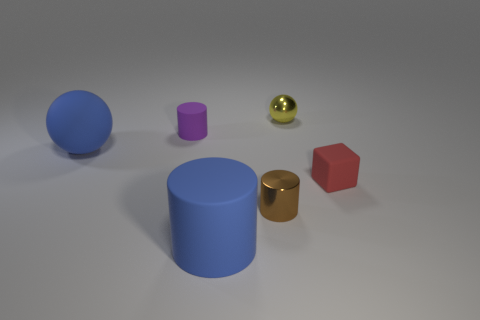Add 2 rubber cylinders. How many objects exist? 8 Subtract all big cylinders. How many cylinders are left? 2 Subtract all brown cylinders. How many cylinders are left? 2 Subtract all cubes. How many objects are left? 5 Subtract 0 red cylinders. How many objects are left? 6 Subtract all yellow cylinders. Subtract all brown spheres. How many cylinders are left? 3 Subtract all big brown rubber spheres. Subtract all rubber objects. How many objects are left? 2 Add 1 large blue rubber balls. How many large blue rubber balls are left? 2 Add 5 tiny brown metallic spheres. How many tiny brown metallic spheres exist? 5 